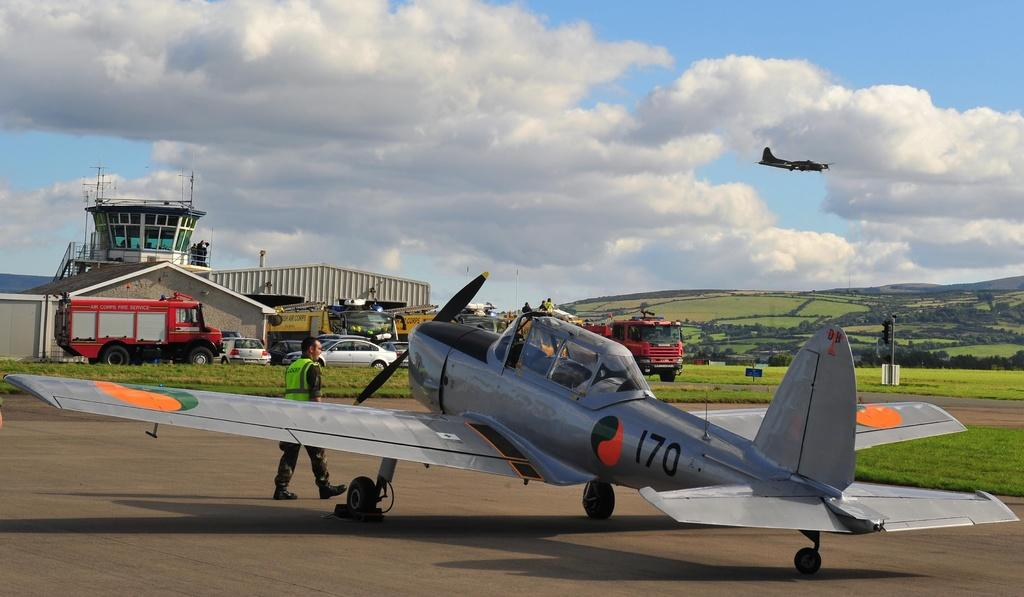<image>
Give a short and clear explanation of the subsequent image. Plane number 170 getting ready for takeoff into the sky, 